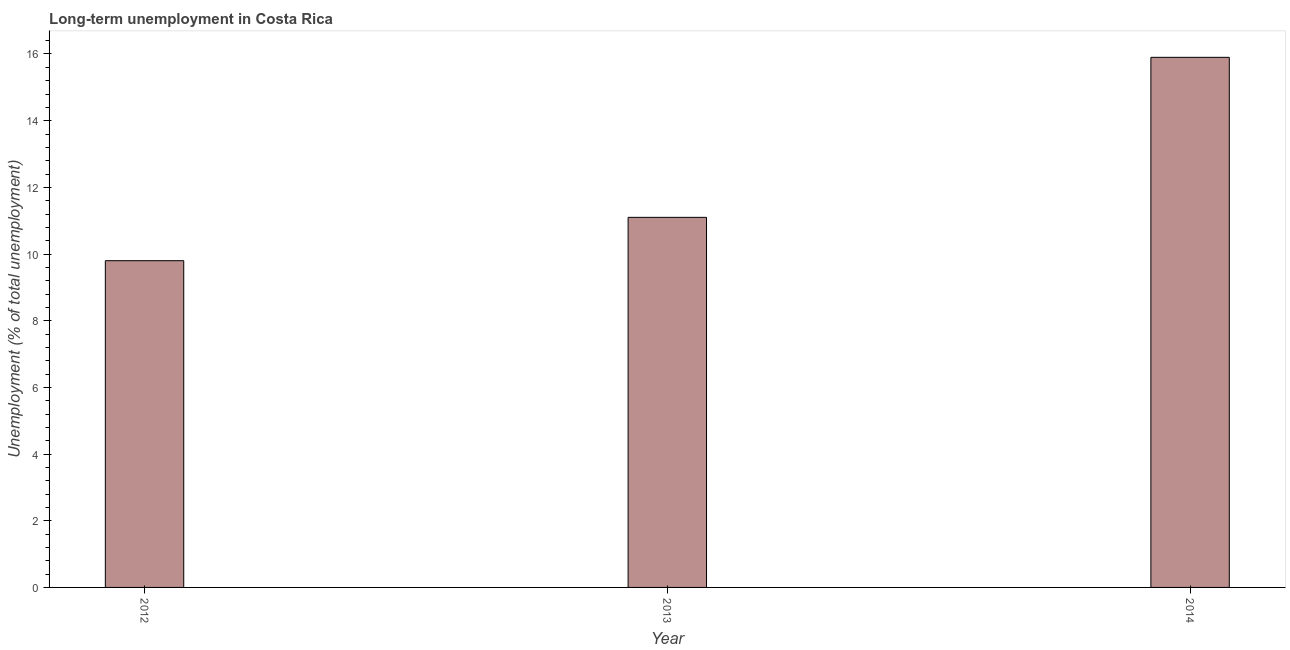Does the graph contain grids?
Ensure brevity in your answer.  No. What is the title of the graph?
Ensure brevity in your answer.  Long-term unemployment in Costa Rica. What is the label or title of the X-axis?
Your answer should be compact. Year. What is the label or title of the Y-axis?
Make the answer very short. Unemployment (% of total unemployment). What is the long-term unemployment in 2014?
Provide a short and direct response. 15.9. Across all years, what is the maximum long-term unemployment?
Offer a terse response. 15.9. Across all years, what is the minimum long-term unemployment?
Your answer should be compact. 9.8. In which year was the long-term unemployment maximum?
Offer a terse response. 2014. What is the sum of the long-term unemployment?
Ensure brevity in your answer.  36.8. What is the average long-term unemployment per year?
Your response must be concise. 12.27. What is the median long-term unemployment?
Offer a very short reply. 11.1. What is the ratio of the long-term unemployment in 2012 to that in 2013?
Keep it short and to the point. 0.88. Is the long-term unemployment in 2012 less than that in 2013?
Your answer should be very brief. Yes. Is the difference between the long-term unemployment in 2012 and 2014 greater than the difference between any two years?
Offer a terse response. Yes. What is the difference between the highest and the second highest long-term unemployment?
Give a very brief answer. 4.8. How many bars are there?
Offer a very short reply. 3. Are all the bars in the graph horizontal?
Provide a short and direct response. No. How many years are there in the graph?
Your response must be concise. 3. What is the difference between two consecutive major ticks on the Y-axis?
Your answer should be compact. 2. What is the Unemployment (% of total unemployment) in 2012?
Make the answer very short. 9.8. What is the Unemployment (% of total unemployment) in 2013?
Give a very brief answer. 11.1. What is the Unemployment (% of total unemployment) of 2014?
Offer a very short reply. 15.9. What is the difference between the Unemployment (% of total unemployment) in 2012 and 2013?
Your response must be concise. -1.3. What is the difference between the Unemployment (% of total unemployment) in 2012 and 2014?
Your answer should be compact. -6.1. What is the difference between the Unemployment (% of total unemployment) in 2013 and 2014?
Give a very brief answer. -4.8. What is the ratio of the Unemployment (% of total unemployment) in 2012 to that in 2013?
Provide a short and direct response. 0.88. What is the ratio of the Unemployment (% of total unemployment) in 2012 to that in 2014?
Provide a succinct answer. 0.62. What is the ratio of the Unemployment (% of total unemployment) in 2013 to that in 2014?
Make the answer very short. 0.7. 